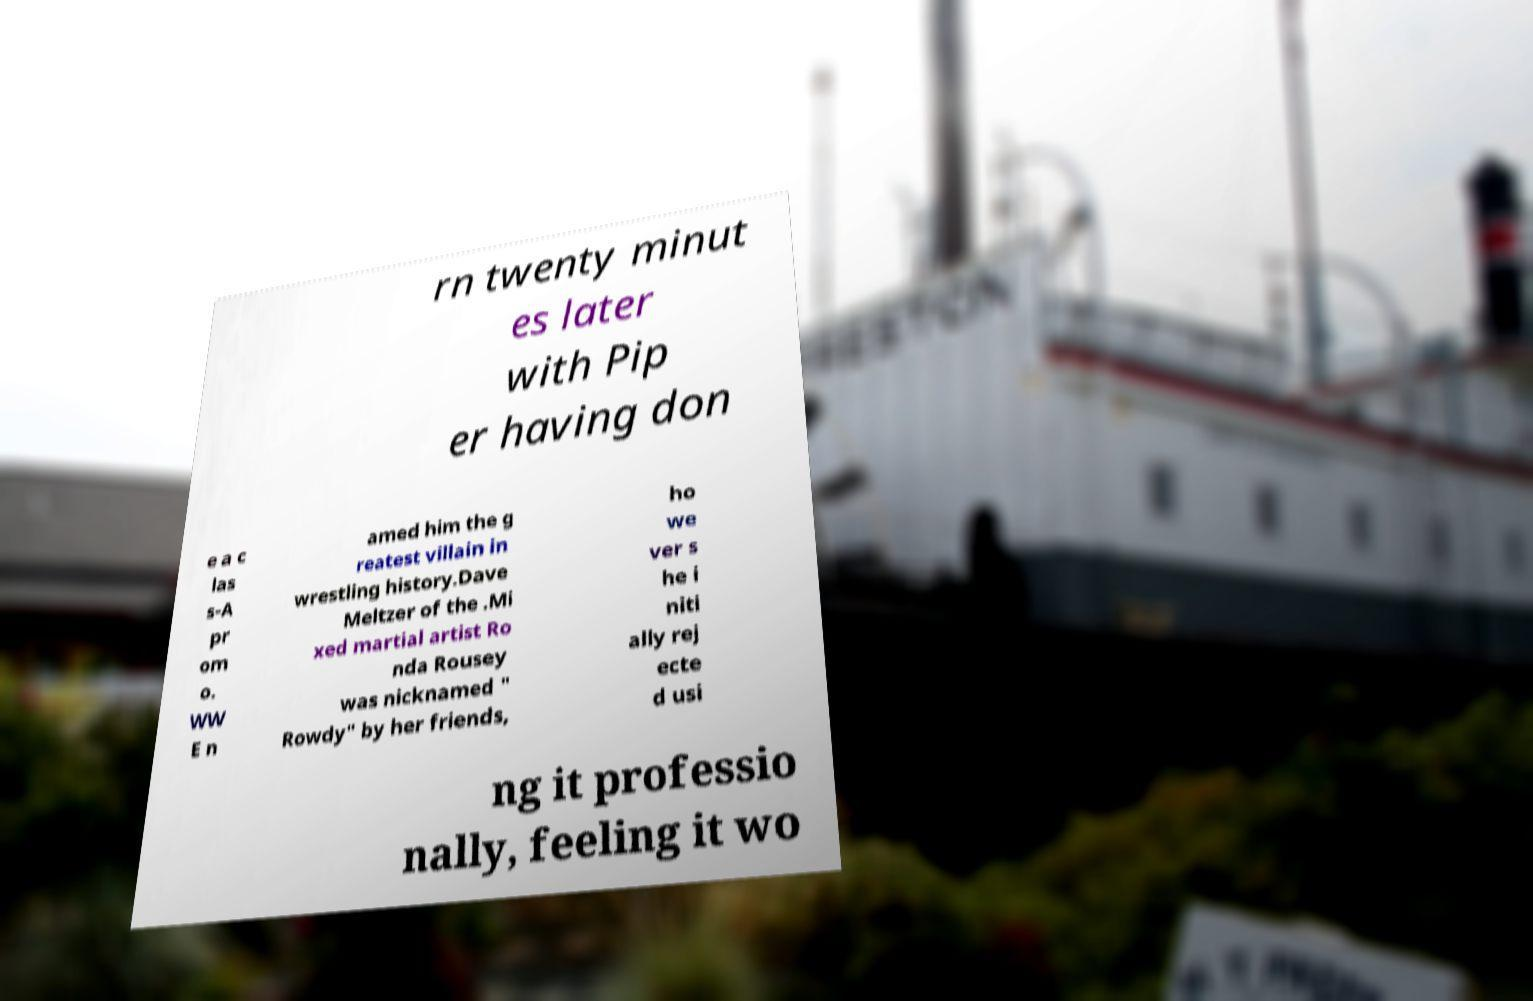Please read and relay the text visible in this image. What does it say? rn twenty minut es later with Pip er having don e a c las s-A pr om o. WW E n amed him the g reatest villain in wrestling history.Dave Meltzer of the .Mi xed martial artist Ro nda Rousey was nicknamed " Rowdy" by her friends, ho we ver s he i niti ally rej ecte d usi ng it professio nally, feeling it wo 